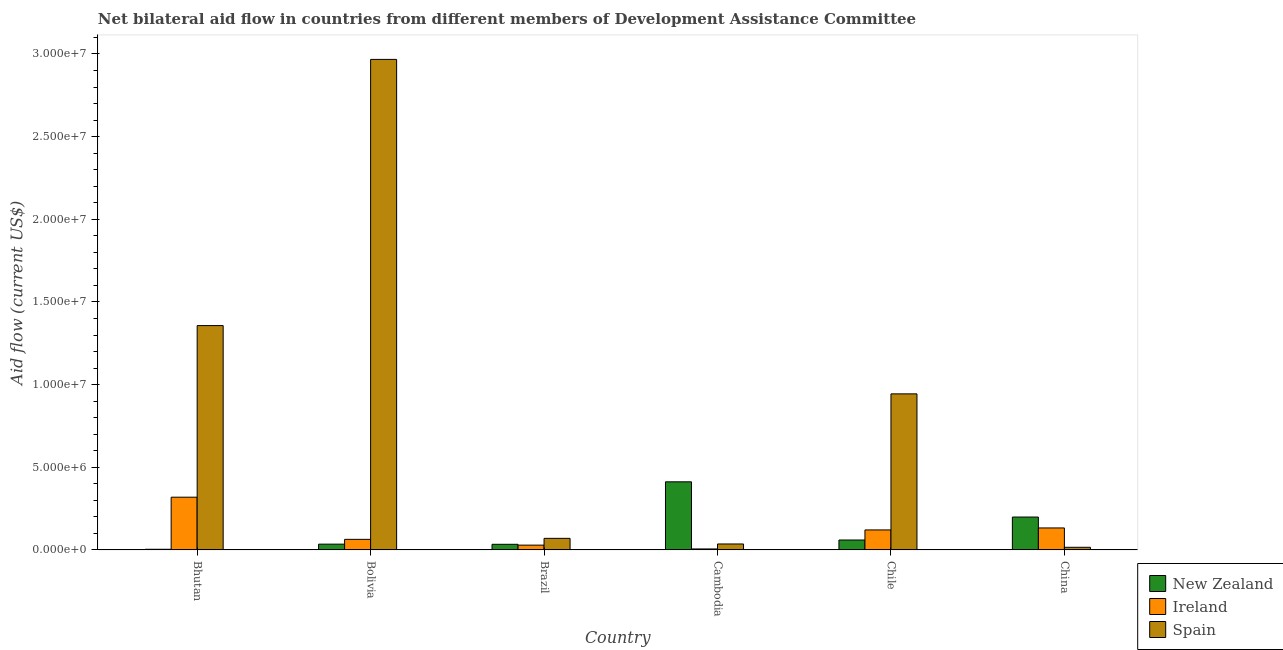How many groups of bars are there?
Ensure brevity in your answer.  6. Are the number of bars per tick equal to the number of legend labels?
Your answer should be compact. Yes. Are the number of bars on each tick of the X-axis equal?
Your answer should be compact. Yes. How many bars are there on the 4th tick from the left?
Keep it short and to the point. 3. What is the label of the 2nd group of bars from the left?
Provide a succinct answer. Bolivia. In how many cases, is the number of bars for a given country not equal to the number of legend labels?
Provide a short and direct response. 0. What is the amount of aid provided by ireland in Bolivia?
Your response must be concise. 6.40e+05. Across all countries, what is the maximum amount of aid provided by new zealand?
Provide a short and direct response. 4.12e+06. Across all countries, what is the minimum amount of aid provided by new zealand?
Make the answer very short. 4.00e+04. In which country was the amount of aid provided by new zealand maximum?
Your answer should be very brief. Cambodia. In which country was the amount of aid provided by ireland minimum?
Provide a succinct answer. Cambodia. What is the total amount of aid provided by new zealand in the graph?
Your answer should be compact. 7.44e+06. What is the difference between the amount of aid provided by spain in Bhutan and that in Bolivia?
Your answer should be compact. -1.61e+07. What is the difference between the amount of aid provided by ireland in Bolivia and the amount of aid provided by spain in Brazil?
Offer a very short reply. -6.00e+04. What is the average amount of aid provided by ireland per country?
Your answer should be compact. 1.12e+06. What is the difference between the amount of aid provided by ireland and amount of aid provided by new zealand in China?
Your response must be concise. -6.60e+05. In how many countries, is the amount of aid provided by new zealand greater than 15000000 US$?
Provide a succinct answer. 0. What is the ratio of the amount of aid provided by new zealand in Bhutan to that in Chile?
Ensure brevity in your answer.  0.07. Is the difference between the amount of aid provided by spain in Bolivia and Brazil greater than the difference between the amount of aid provided by ireland in Bolivia and Brazil?
Your response must be concise. Yes. What is the difference between the highest and the second highest amount of aid provided by new zealand?
Offer a terse response. 2.13e+06. What is the difference between the highest and the lowest amount of aid provided by new zealand?
Provide a short and direct response. 4.08e+06. In how many countries, is the amount of aid provided by new zealand greater than the average amount of aid provided by new zealand taken over all countries?
Give a very brief answer. 2. What does the 1st bar from the left in Brazil represents?
Give a very brief answer. New Zealand. What does the 2nd bar from the right in China represents?
Give a very brief answer. Ireland. How many bars are there?
Provide a short and direct response. 18. Where does the legend appear in the graph?
Offer a terse response. Bottom right. What is the title of the graph?
Ensure brevity in your answer.  Net bilateral aid flow in countries from different members of Development Assistance Committee. Does "Unemployment benefits" appear as one of the legend labels in the graph?
Offer a very short reply. No. What is the Aid flow (current US$) of New Zealand in Bhutan?
Your response must be concise. 4.00e+04. What is the Aid flow (current US$) of Ireland in Bhutan?
Ensure brevity in your answer.  3.19e+06. What is the Aid flow (current US$) in Spain in Bhutan?
Your answer should be very brief. 1.36e+07. What is the Aid flow (current US$) of Ireland in Bolivia?
Keep it short and to the point. 6.40e+05. What is the Aid flow (current US$) of Spain in Bolivia?
Ensure brevity in your answer.  2.97e+07. What is the Aid flow (current US$) in New Zealand in Cambodia?
Offer a terse response. 4.12e+06. What is the Aid flow (current US$) of Spain in Cambodia?
Your answer should be very brief. 3.60e+05. What is the Aid flow (current US$) of New Zealand in Chile?
Your answer should be very brief. 6.00e+05. What is the Aid flow (current US$) in Ireland in Chile?
Ensure brevity in your answer.  1.21e+06. What is the Aid flow (current US$) of Spain in Chile?
Your response must be concise. 9.44e+06. What is the Aid flow (current US$) in New Zealand in China?
Keep it short and to the point. 1.99e+06. What is the Aid flow (current US$) in Ireland in China?
Provide a short and direct response. 1.33e+06. What is the Aid flow (current US$) of Spain in China?
Provide a succinct answer. 1.60e+05. Across all countries, what is the maximum Aid flow (current US$) in New Zealand?
Your answer should be very brief. 4.12e+06. Across all countries, what is the maximum Aid flow (current US$) in Ireland?
Provide a succinct answer. 3.19e+06. Across all countries, what is the maximum Aid flow (current US$) of Spain?
Your answer should be compact. 2.97e+07. Across all countries, what is the minimum Aid flow (current US$) in Spain?
Your response must be concise. 1.60e+05. What is the total Aid flow (current US$) in New Zealand in the graph?
Ensure brevity in your answer.  7.44e+06. What is the total Aid flow (current US$) of Ireland in the graph?
Give a very brief answer. 6.72e+06. What is the total Aid flow (current US$) in Spain in the graph?
Your answer should be very brief. 5.39e+07. What is the difference between the Aid flow (current US$) in New Zealand in Bhutan and that in Bolivia?
Keep it short and to the point. -3.10e+05. What is the difference between the Aid flow (current US$) of Ireland in Bhutan and that in Bolivia?
Provide a short and direct response. 2.55e+06. What is the difference between the Aid flow (current US$) of Spain in Bhutan and that in Bolivia?
Make the answer very short. -1.61e+07. What is the difference between the Aid flow (current US$) of Ireland in Bhutan and that in Brazil?
Your answer should be compact. 2.90e+06. What is the difference between the Aid flow (current US$) of Spain in Bhutan and that in Brazil?
Give a very brief answer. 1.29e+07. What is the difference between the Aid flow (current US$) of New Zealand in Bhutan and that in Cambodia?
Provide a short and direct response. -4.08e+06. What is the difference between the Aid flow (current US$) in Ireland in Bhutan and that in Cambodia?
Give a very brief answer. 3.13e+06. What is the difference between the Aid flow (current US$) in Spain in Bhutan and that in Cambodia?
Your response must be concise. 1.32e+07. What is the difference between the Aid flow (current US$) of New Zealand in Bhutan and that in Chile?
Keep it short and to the point. -5.60e+05. What is the difference between the Aid flow (current US$) of Ireland in Bhutan and that in Chile?
Offer a terse response. 1.98e+06. What is the difference between the Aid flow (current US$) of Spain in Bhutan and that in Chile?
Provide a succinct answer. 4.13e+06. What is the difference between the Aid flow (current US$) in New Zealand in Bhutan and that in China?
Provide a succinct answer. -1.95e+06. What is the difference between the Aid flow (current US$) in Ireland in Bhutan and that in China?
Ensure brevity in your answer.  1.86e+06. What is the difference between the Aid flow (current US$) in Spain in Bhutan and that in China?
Offer a terse response. 1.34e+07. What is the difference between the Aid flow (current US$) of Ireland in Bolivia and that in Brazil?
Keep it short and to the point. 3.50e+05. What is the difference between the Aid flow (current US$) in Spain in Bolivia and that in Brazil?
Ensure brevity in your answer.  2.90e+07. What is the difference between the Aid flow (current US$) of New Zealand in Bolivia and that in Cambodia?
Make the answer very short. -3.77e+06. What is the difference between the Aid flow (current US$) in Ireland in Bolivia and that in Cambodia?
Keep it short and to the point. 5.80e+05. What is the difference between the Aid flow (current US$) of Spain in Bolivia and that in Cambodia?
Provide a short and direct response. 2.93e+07. What is the difference between the Aid flow (current US$) of New Zealand in Bolivia and that in Chile?
Ensure brevity in your answer.  -2.50e+05. What is the difference between the Aid flow (current US$) in Ireland in Bolivia and that in Chile?
Make the answer very short. -5.70e+05. What is the difference between the Aid flow (current US$) of Spain in Bolivia and that in Chile?
Provide a succinct answer. 2.02e+07. What is the difference between the Aid flow (current US$) of New Zealand in Bolivia and that in China?
Your answer should be very brief. -1.64e+06. What is the difference between the Aid flow (current US$) of Ireland in Bolivia and that in China?
Ensure brevity in your answer.  -6.90e+05. What is the difference between the Aid flow (current US$) in Spain in Bolivia and that in China?
Make the answer very short. 2.95e+07. What is the difference between the Aid flow (current US$) in New Zealand in Brazil and that in Cambodia?
Your answer should be very brief. -3.78e+06. What is the difference between the Aid flow (current US$) of Ireland in Brazil and that in Cambodia?
Give a very brief answer. 2.30e+05. What is the difference between the Aid flow (current US$) of New Zealand in Brazil and that in Chile?
Your answer should be compact. -2.60e+05. What is the difference between the Aid flow (current US$) in Ireland in Brazil and that in Chile?
Offer a terse response. -9.20e+05. What is the difference between the Aid flow (current US$) in Spain in Brazil and that in Chile?
Provide a short and direct response. -8.74e+06. What is the difference between the Aid flow (current US$) in New Zealand in Brazil and that in China?
Make the answer very short. -1.65e+06. What is the difference between the Aid flow (current US$) in Ireland in Brazil and that in China?
Your answer should be very brief. -1.04e+06. What is the difference between the Aid flow (current US$) in Spain in Brazil and that in China?
Your response must be concise. 5.40e+05. What is the difference between the Aid flow (current US$) in New Zealand in Cambodia and that in Chile?
Ensure brevity in your answer.  3.52e+06. What is the difference between the Aid flow (current US$) in Ireland in Cambodia and that in Chile?
Provide a succinct answer. -1.15e+06. What is the difference between the Aid flow (current US$) in Spain in Cambodia and that in Chile?
Make the answer very short. -9.08e+06. What is the difference between the Aid flow (current US$) of New Zealand in Cambodia and that in China?
Ensure brevity in your answer.  2.13e+06. What is the difference between the Aid flow (current US$) of Ireland in Cambodia and that in China?
Ensure brevity in your answer.  -1.27e+06. What is the difference between the Aid flow (current US$) of Spain in Cambodia and that in China?
Provide a succinct answer. 2.00e+05. What is the difference between the Aid flow (current US$) of New Zealand in Chile and that in China?
Provide a succinct answer. -1.39e+06. What is the difference between the Aid flow (current US$) of Ireland in Chile and that in China?
Offer a very short reply. -1.20e+05. What is the difference between the Aid flow (current US$) of Spain in Chile and that in China?
Provide a short and direct response. 9.28e+06. What is the difference between the Aid flow (current US$) in New Zealand in Bhutan and the Aid flow (current US$) in Ireland in Bolivia?
Your response must be concise. -6.00e+05. What is the difference between the Aid flow (current US$) of New Zealand in Bhutan and the Aid flow (current US$) of Spain in Bolivia?
Provide a succinct answer. -2.96e+07. What is the difference between the Aid flow (current US$) of Ireland in Bhutan and the Aid flow (current US$) of Spain in Bolivia?
Offer a very short reply. -2.65e+07. What is the difference between the Aid flow (current US$) of New Zealand in Bhutan and the Aid flow (current US$) of Ireland in Brazil?
Provide a short and direct response. -2.50e+05. What is the difference between the Aid flow (current US$) of New Zealand in Bhutan and the Aid flow (current US$) of Spain in Brazil?
Keep it short and to the point. -6.60e+05. What is the difference between the Aid flow (current US$) in Ireland in Bhutan and the Aid flow (current US$) in Spain in Brazil?
Give a very brief answer. 2.49e+06. What is the difference between the Aid flow (current US$) of New Zealand in Bhutan and the Aid flow (current US$) of Spain in Cambodia?
Ensure brevity in your answer.  -3.20e+05. What is the difference between the Aid flow (current US$) in Ireland in Bhutan and the Aid flow (current US$) in Spain in Cambodia?
Make the answer very short. 2.83e+06. What is the difference between the Aid flow (current US$) of New Zealand in Bhutan and the Aid flow (current US$) of Ireland in Chile?
Offer a terse response. -1.17e+06. What is the difference between the Aid flow (current US$) in New Zealand in Bhutan and the Aid flow (current US$) in Spain in Chile?
Provide a succinct answer. -9.40e+06. What is the difference between the Aid flow (current US$) of Ireland in Bhutan and the Aid flow (current US$) of Spain in Chile?
Your response must be concise. -6.25e+06. What is the difference between the Aid flow (current US$) in New Zealand in Bhutan and the Aid flow (current US$) in Ireland in China?
Provide a short and direct response. -1.29e+06. What is the difference between the Aid flow (current US$) in New Zealand in Bhutan and the Aid flow (current US$) in Spain in China?
Your answer should be compact. -1.20e+05. What is the difference between the Aid flow (current US$) of Ireland in Bhutan and the Aid flow (current US$) of Spain in China?
Give a very brief answer. 3.03e+06. What is the difference between the Aid flow (current US$) of New Zealand in Bolivia and the Aid flow (current US$) of Ireland in Brazil?
Your answer should be compact. 6.00e+04. What is the difference between the Aid flow (current US$) of New Zealand in Bolivia and the Aid flow (current US$) of Spain in Brazil?
Ensure brevity in your answer.  -3.50e+05. What is the difference between the Aid flow (current US$) in Ireland in Bolivia and the Aid flow (current US$) in Spain in Brazil?
Keep it short and to the point. -6.00e+04. What is the difference between the Aid flow (current US$) of New Zealand in Bolivia and the Aid flow (current US$) of Ireland in Cambodia?
Your answer should be compact. 2.90e+05. What is the difference between the Aid flow (current US$) in New Zealand in Bolivia and the Aid flow (current US$) in Spain in Cambodia?
Make the answer very short. -10000. What is the difference between the Aid flow (current US$) of New Zealand in Bolivia and the Aid flow (current US$) of Ireland in Chile?
Ensure brevity in your answer.  -8.60e+05. What is the difference between the Aid flow (current US$) in New Zealand in Bolivia and the Aid flow (current US$) in Spain in Chile?
Your answer should be compact. -9.09e+06. What is the difference between the Aid flow (current US$) of Ireland in Bolivia and the Aid flow (current US$) of Spain in Chile?
Give a very brief answer. -8.80e+06. What is the difference between the Aid flow (current US$) in New Zealand in Bolivia and the Aid flow (current US$) in Ireland in China?
Offer a very short reply. -9.80e+05. What is the difference between the Aid flow (current US$) in New Zealand in Bolivia and the Aid flow (current US$) in Spain in China?
Keep it short and to the point. 1.90e+05. What is the difference between the Aid flow (current US$) in Ireland in Bolivia and the Aid flow (current US$) in Spain in China?
Offer a terse response. 4.80e+05. What is the difference between the Aid flow (current US$) in New Zealand in Brazil and the Aid flow (current US$) in Ireland in Chile?
Ensure brevity in your answer.  -8.70e+05. What is the difference between the Aid flow (current US$) in New Zealand in Brazil and the Aid flow (current US$) in Spain in Chile?
Offer a terse response. -9.10e+06. What is the difference between the Aid flow (current US$) of Ireland in Brazil and the Aid flow (current US$) of Spain in Chile?
Give a very brief answer. -9.15e+06. What is the difference between the Aid flow (current US$) in New Zealand in Brazil and the Aid flow (current US$) in Ireland in China?
Give a very brief answer. -9.90e+05. What is the difference between the Aid flow (current US$) in New Zealand in Brazil and the Aid flow (current US$) in Spain in China?
Make the answer very short. 1.80e+05. What is the difference between the Aid flow (current US$) of New Zealand in Cambodia and the Aid flow (current US$) of Ireland in Chile?
Offer a very short reply. 2.91e+06. What is the difference between the Aid flow (current US$) in New Zealand in Cambodia and the Aid flow (current US$) in Spain in Chile?
Keep it short and to the point. -5.32e+06. What is the difference between the Aid flow (current US$) of Ireland in Cambodia and the Aid flow (current US$) of Spain in Chile?
Your response must be concise. -9.38e+06. What is the difference between the Aid flow (current US$) of New Zealand in Cambodia and the Aid flow (current US$) of Ireland in China?
Provide a succinct answer. 2.79e+06. What is the difference between the Aid flow (current US$) in New Zealand in Cambodia and the Aid flow (current US$) in Spain in China?
Make the answer very short. 3.96e+06. What is the difference between the Aid flow (current US$) in Ireland in Cambodia and the Aid flow (current US$) in Spain in China?
Your answer should be compact. -1.00e+05. What is the difference between the Aid flow (current US$) in New Zealand in Chile and the Aid flow (current US$) in Ireland in China?
Keep it short and to the point. -7.30e+05. What is the difference between the Aid flow (current US$) in Ireland in Chile and the Aid flow (current US$) in Spain in China?
Offer a terse response. 1.05e+06. What is the average Aid flow (current US$) of New Zealand per country?
Offer a very short reply. 1.24e+06. What is the average Aid flow (current US$) in Ireland per country?
Your response must be concise. 1.12e+06. What is the average Aid flow (current US$) in Spain per country?
Make the answer very short. 8.98e+06. What is the difference between the Aid flow (current US$) in New Zealand and Aid flow (current US$) in Ireland in Bhutan?
Ensure brevity in your answer.  -3.15e+06. What is the difference between the Aid flow (current US$) of New Zealand and Aid flow (current US$) of Spain in Bhutan?
Offer a terse response. -1.35e+07. What is the difference between the Aid flow (current US$) in Ireland and Aid flow (current US$) in Spain in Bhutan?
Ensure brevity in your answer.  -1.04e+07. What is the difference between the Aid flow (current US$) of New Zealand and Aid flow (current US$) of Ireland in Bolivia?
Provide a succinct answer. -2.90e+05. What is the difference between the Aid flow (current US$) of New Zealand and Aid flow (current US$) of Spain in Bolivia?
Offer a terse response. -2.93e+07. What is the difference between the Aid flow (current US$) of Ireland and Aid flow (current US$) of Spain in Bolivia?
Your answer should be very brief. -2.90e+07. What is the difference between the Aid flow (current US$) in New Zealand and Aid flow (current US$) in Ireland in Brazil?
Give a very brief answer. 5.00e+04. What is the difference between the Aid flow (current US$) of New Zealand and Aid flow (current US$) of Spain in Brazil?
Your response must be concise. -3.60e+05. What is the difference between the Aid flow (current US$) in Ireland and Aid flow (current US$) in Spain in Brazil?
Your answer should be very brief. -4.10e+05. What is the difference between the Aid flow (current US$) in New Zealand and Aid flow (current US$) in Ireland in Cambodia?
Ensure brevity in your answer.  4.06e+06. What is the difference between the Aid flow (current US$) of New Zealand and Aid flow (current US$) of Spain in Cambodia?
Provide a succinct answer. 3.76e+06. What is the difference between the Aid flow (current US$) of Ireland and Aid flow (current US$) of Spain in Cambodia?
Your answer should be compact. -3.00e+05. What is the difference between the Aid flow (current US$) of New Zealand and Aid flow (current US$) of Ireland in Chile?
Keep it short and to the point. -6.10e+05. What is the difference between the Aid flow (current US$) of New Zealand and Aid flow (current US$) of Spain in Chile?
Make the answer very short. -8.84e+06. What is the difference between the Aid flow (current US$) in Ireland and Aid flow (current US$) in Spain in Chile?
Make the answer very short. -8.23e+06. What is the difference between the Aid flow (current US$) in New Zealand and Aid flow (current US$) in Ireland in China?
Provide a succinct answer. 6.60e+05. What is the difference between the Aid flow (current US$) of New Zealand and Aid flow (current US$) of Spain in China?
Your answer should be very brief. 1.83e+06. What is the difference between the Aid flow (current US$) in Ireland and Aid flow (current US$) in Spain in China?
Provide a succinct answer. 1.17e+06. What is the ratio of the Aid flow (current US$) in New Zealand in Bhutan to that in Bolivia?
Provide a succinct answer. 0.11. What is the ratio of the Aid flow (current US$) of Ireland in Bhutan to that in Bolivia?
Offer a terse response. 4.98. What is the ratio of the Aid flow (current US$) in Spain in Bhutan to that in Bolivia?
Offer a terse response. 0.46. What is the ratio of the Aid flow (current US$) of New Zealand in Bhutan to that in Brazil?
Your answer should be compact. 0.12. What is the ratio of the Aid flow (current US$) in Ireland in Bhutan to that in Brazil?
Offer a terse response. 11. What is the ratio of the Aid flow (current US$) in Spain in Bhutan to that in Brazil?
Ensure brevity in your answer.  19.39. What is the ratio of the Aid flow (current US$) of New Zealand in Bhutan to that in Cambodia?
Offer a terse response. 0.01. What is the ratio of the Aid flow (current US$) of Ireland in Bhutan to that in Cambodia?
Your response must be concise. 53.17. What is the ratio of the Aid flow (current US$) in Spain in Bhutan to that in Cambodia?
Your response must be concise. 37.69. What is the ratio of the Aid flow (current US$) of New Zealand in Bhutan to that in Chile?
Your answer should be very brief. 0.07. What is the ratio of the Aid flow (current US$) in Ireland in Bhutan to that in Chile?
Provide a short and direct response. 2.64. What is the ratio of the Aid flow (current US$) in Spain in Bhutan to that in Chile?
Offer a terse response. 1.44. What is the ratio of the Aid flow (current US$) in New Zealand in Bhutan to that in China?
Make the answer very short. 0.02. What is the ratio of the Aid flow (current US$) of Ireland in Bhutan to that in China?
Offer a terse response. 2.4. What is the ratio of the Aid flow (current US$) of Spain in Bhutan to that in China?
Offer a very short reply. 84.81. What is the ratio of the Aid flow (current US$) in New Zealand in Bolivia to that in Brazil?
Make the answer very short. 1.03. What is the ratio of the Aid flow (current US$) in Ireland in Bolivia to that in Brazil?
Keep it short and to the point. 2.21. What is the ratio of the Aid flow (current US$) in Spain in Bolivia to that in Brazil?
Offer a very short reply. 42.39. What is the ratio of the Aid flow (current US$) of New Zealand in Bolivia to that in Cambodia?
Ensure brevity in your answer.  0.09. What is the ratio of the Aid flow (current US$) in Ireland in Bolivia to that in Cambodia?
Provide a short and direct response. 10.67. What is the ratio of the Aid flow (current US$) in Spain in Bolivia to that in Cambodia?
Make the answer very short. 82.42. What is the ratio of the Aid flow (current US$) in New Zealand in Bolivia to that in Chile?
Provide a short and direct response. 0.58. What is the ratio of the Aid flow (current US$) in Ireland in Bolivia to that in Chile?
Offer a terse response. 0.53. What is the ratio of the Aid flow (current US$) in Spain in Bolivia to that in Chile?
Your answer should be very brief. 3.14. What is the ratio of the Aid flow (current US$) of New Zealand in Bolivia to that in China?
Your response must be concise. 0.18. What is the ratio of the Aid flow (current US$) of Ireland in Bolivia to that in China?
Make the answer very short. 0.48. What is the ratio of the Aid flow (current US$) of Spain in Bolivia to that in China?
Offer a terse response. 185.44. What is the ratio of the Aid flow (current US$) in New Zealand in Brazil to that in Cambodia?
Keep it short and to the point. 0.08. What is the ratio of the Aid flow (current US$) of Ireland in Brazil to that in Cambodia?
Provide a short and direct response. 4.83. What is the ratio of the Aid flow (current US$) in Spain in Brazil to that in Cambodia?
Provide a succinct answer. 1.94. What is the ratio of the Aid flow (current US$) of New Zealand in Brazil to that in Chile?
Provide a succinct answer. 0.57. What is the ratio of the Aid flow (current US$) of Ireland in Brazil to that in Chile?
Your answer should be very brief. 0.24. What is the ratio of the Aid flow (current US$) of Spain in Brazil to that in Chile?
Your response must be concise. 0.07. What is the ratio of the Aid flow (current US$) of New Zealand in Brazil to that in China?
Make the answer very short. 0.17. What is the ratio of the Aid flow (current US$) in Ireland in Brazil to that in China?
Ensure brevity in your answer.  0.22. What is the ratio of the Aid flow (current US$) of Spain in Brazil to that in China?
Provide a short and direct response. 4.38. What is the ratio of the Aid flow (current US$) of New Zealand in Cambodia to that in Chile?
Offer a terse response. 6.87. What is the ratio of the Aid flow (current US$) of Ireland in Cambodia to that in Chile?
Your answer should be compact. 0.05. What is the ratio of the Aid flow (current US$) in Spain in Cambodia to that in Chile?
Your answer should be compact. 0.04. What is the ratio of the Aid flow (current US$) of New Zealand in Cambodia to that in China?
Keep it short and to the point. 2.07. What is the ratio of the Aid flow (current US$) of Ireland in Cambodia to that in China?
Your answer should be very brief. 0.05. What is the ratio of the Aid flow (current US$) of Spain in Cambodia to that in China?
Make the answer very short. 2.25. What is the ratio of the Aid flow (current US$) of New Zealand in Chile to that in China?
Your answer should be very brief. 0.3. What is the ratio of the Aid flow (current US$) in Ireland in Chile to that in China?
Provide a short and direct response. 0.91. What is the difference between the highest and the second highest Aid flow (current US$) of New Zealand?
Your answer should be very brief. 2.13e+06. What is the difference between the highest and the second highest Aid flow (current US$) in Ireland?
Offer a very short reply. 1.86e+06. What is the difference between the highest and the second highest Aid flow (current US$) of Spain?
Your answer should be compact. 1.61e+07. What is the difference between the highest and the lowest Aid flow (current US$) of New Zealand?
Your answer should be very brief. 4.08e+06. What is the difference between the highest and the lowest Aid flow (current US$) of Ireland?
Ensure brevity in your answer.  3.13e+06. What is the difference between the highest and the lowest Aid flow (current US$) of Spain?
Provide a succinct answer. 2.95e+07. 